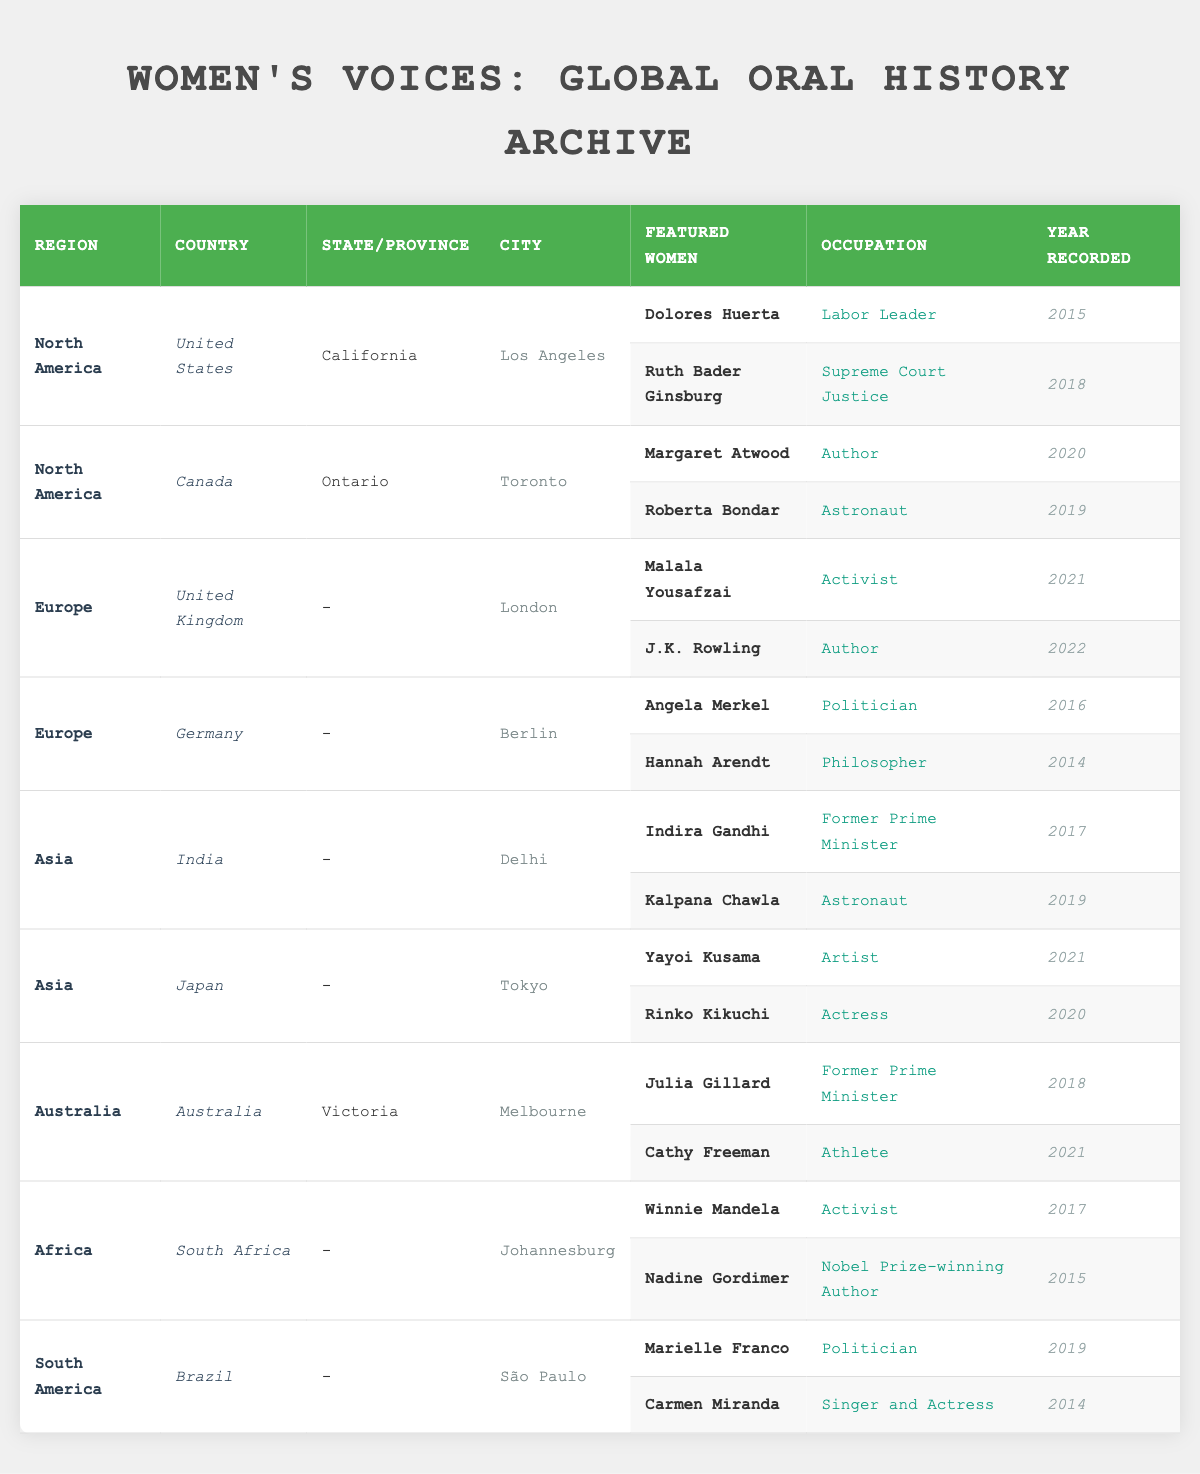What regions are represented in the table? The regions listed in the table are: North America, Europe, Asia, Australia, Africa, and South America. These can be identified from the first column of the table.
Answer: North America, Europe, Asia, Australia, Africa, South America Which country has the most featured women listed? By examining the table, Canada and the United States each have 2 featured women. No other country has more than that, which indicates that Canada and the United States are tied for the most featured women.
Answer: Canada and United States (2 each) Who were the featured women from India and what were their occupations? In the table, the featured women from India are Indira Gandhi, who was a Former Prime Minister, and Kalpana Chawla, who was an Astronaut. This information is found in the rows under the 'India' entry.
Answer: Indira Gandhi (Former Prime Minister), Kalpana Chawla (Astronaut) Did any featured women record their stories in the same year in any country? Yes, in Canada, both Margaret Atwood and Roberta Bondar recorded their stories in successive years (2019 and 2020). In South Africa, both Winnie Mandela and Nadine Gordimer have recordings dated 2015. Hence, the answer is yes.
Answer: Yes What is the average year of recording for featured women in Australia? The featured women from Australia are Julia Gillard (2018) and Cathy Freeman (2021). The average is calculated as (2018 + 2021) / 2 = 2019.5. Since we're looking for a year, we can represent this as 2020 when rounded.
Answer: 2020 Are there any featured women from the United Kingdom who recorded stories before 2021? Yes, in the United Kingdom, J.K. Rowling recorded her story in 2022, and Malala Yousafzai recorded hers in 2021. Therefore, there are no women recorded before 2021 in this country.
Answer: No Which woman had a career in arts and from which country is she? Yayoi Kusama, listed as an Artist, is the featured woman associated with arts from Japan. This can be determined by reading through the relevant rows under the Asia region.
Answer: Yayoi Kusama (Japan) What is the occupation of the woman recorded in South Africa in 2017? The woman recorded in 2017 in South Africa is Winnie Mandela, whose occupation was Activist. This can be confirmed by examining the respective entry in the table.
Answer: Activist Which country has featured a Nobel Prize-winning author? South Africa has featured a Nobel Prize-winning author, Nadine Gordimer, noted in the related row in the table. This is confirmed from the details provided for South Africa.
Answer: South Africa How many featured women are athletes listed in the table? Cathy Freeman from Australia is the only athlete recorded in the table. After checking the relevant information for each country, only her occupation fits the description of an athlete.
Answer: 1 